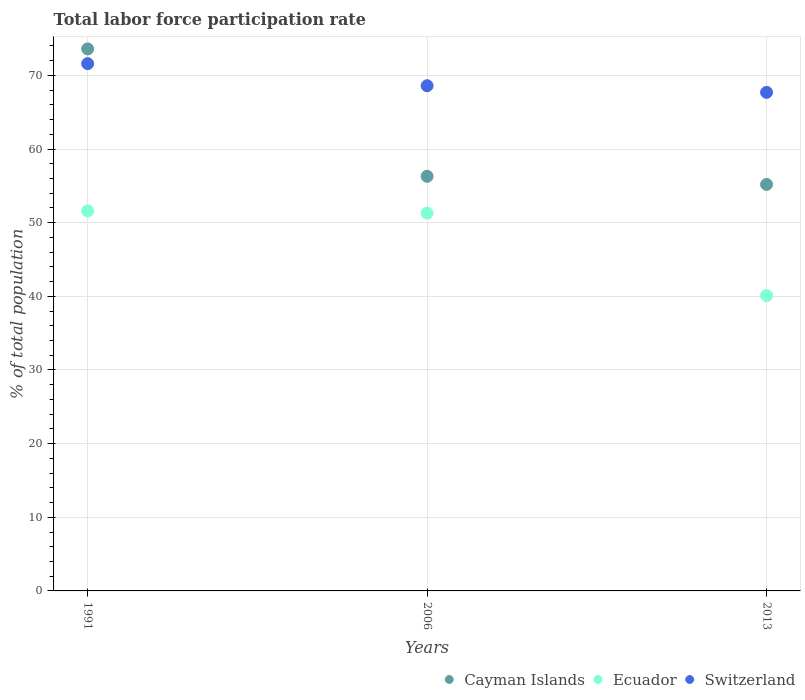What is the total labor force participation rate in Cayman Islands in 1991?
Provide a succinct answer. 73.6. Across all years, what is the maximum total labor force participation rate in Switzerland?
Ensure brevity in your answer.  71.6. Across all years, what is the minimum total labor force participation rate in Switzerland?
Offer a very short reply. 67.7. In which year was the total labor force participation rate in Switzerland maximum?
Make the answer very short. 1991. What is the total total labor force participation rate in Switzerland in the graph?
Ensure brevity in your answer.  207.9. What is the difference between the total labor force participation rate in Ecuador in 1991 and that in 2006?
Keep it short and to the point. 0.3. What is the difference between the total labor force participation rate in Ecuador in 2006 and the total labor force participation rate in Switzerland in 1991?
Your response must be concise. -20.3. What is the average total labor force participation rate in Switzerland per year?
Make the answer very short. 69.3. In how many years, is the total labor force participation rate in Cayman Islands greater than 46 %?
Your answer should be very brief. 3. What is the ratio of the total labor force participation rate in Ecuador in 2006 to that in 2013?
Offer a terse response. 1.28. Is the total labor force participation rate in Cayman Islands in 1991 less than that in 2013?
Provide a succinct answer. No. Is the difference between the total labor force participation rate in Ecuador in 2006 and 2013 greater than the difference between the total labor force participation rate in Cayman Islands in 2006 and 2013?
Keep it short and to the point. Yes. What is the difference between the highest and the second highest total labor force participation rate in Ecuador?
Give a very brief answer. 0.3. What is the difference between the highest and the lowest total labor force participation rate in Switzerland?
Your answer should be very brief. 3.9. In how many years, is the total labor force participation rate in Ecuador greater than the average total labor force participation rate in Ecuador taken over all years?
Provide a short and direct response. 2. Does the total labor force participation rate in Ecuador monotonically increase over the years?
Give a very brief answer. No. Is the total labor force participation rate in Ecuador strictly less than the total labor force participation rate in Cayman Islands over the years?
Your answer should be very brief. Yes. How many dotlines are there?
Provide a succinct answer. 3. What is the title of the graph?
Give a very brief answer. Total labor force participation rate. What is the label or title of the X-axis?
Keep it short and to the point. Years. What is the label or title of the Y-axis?
Give a very brief answer. % of total population. What is the % of total population in Cayman Islands in 1991?
Provide a succinct answer. 73.6. What is the % of total population of Ecuador in 1991?
Provide a short and direct response. 51.6. What is the % of total population of Switzerland in 1991?
Offer a very short reply. 71.6. What is the % of total population of Cayman Islands in 2006?
Keep it short and to the point. 56.3. What is the % of total population in Ecuador in 2006?
Your answer should be compact. 51.3. What is the % of total population of Switzerland in 2006?
Provide a short and direct response. 68.6. What is the % of total population of Cayman Islands in 2013?
Provide a succinct answer. 55.2. What is the % of total population of Ecuador in 2013?
Make the answer very short. 40.1. What is the % of total population of Switzerland in 2013?
Offer a terse response. 67.7. Across all years, what is the maximum % of total population in Cayman Islands?
Ensure brevity in your answer.  73.6. Across all years, what is the maximum % of total population in Ecuador?
Offer a terse response. 51.6. Across all years, what is the maximum % of total population in Switzerland?
Make the answer very short. 71.6. Across all years, what is the minimum % of total population in Cayman Islands?
Give a very brief answer. 55.2. Across all years, what is the minimum % of total population in Ecuador?
Offer a very short reply. 40.1. Across all years, what is the minimum % of total population of Switzerland?
Your answer should be very brief. 67.7. What is the total % of total population in Cayman Islands in the graph?
Give a very brief answer. 185.1. What is the total % of total population in Ecuador in the graph?
Your answer should be compact. 143. What is the total % of total population of Switzerland in the graph?
Your response must be concise. 207.9. What is the difference between the % of total population of Ecuador in 1991 and that in 2013?
Give a very brief answer. 11.5. What is the difference between the % of total population in Ecuador in 2006 and that in 2013?
Keep it short and to the point. 11.2. What is the difference between the % of total population in Cayman Islands in 1991 and the % of total population in Ecuador in 2006?
Give a very brief answer. 22.3. What is the difference between the % of total population in Cayman Islands in 1991 and the % of total population in Switzerland in 2006?
Offer a very short reply. 5. What is the difference between the % of total population in Ecuador in 1991 and the % of total population in Switzerland in 2006?
Ensure brevity in your answer.  -17. What is the difference between the % of total population in Cayman Islands in 1991 and the % of total population in Ecuador in 2013?
Your response must be concise. 33.5. What is the difference between the % of total population in Cayman Islands in 1991 and the % of total population in Switzerland in 2013?
Your answer should be very brief. 5.9. What is the difference between the % of total population in Ecuador in 1991 and the % of total population in Switzerland in 2013?
Offer a terse response. -16.1. What is the difference between the % of total population of Ecuador in 2006 and the % of total population of Switzerland in 2013?
Provide a short and direct response. -16.4. What is the average % of total population of Cayman Islands per year?
Give a very brief answer. 61.7. What is the average % of total population in Ecuador per year?
Offer a terse response. 47.67. What is the average % of total population of Switzerland per year?
Offer a terse response. 69.3. In the year 1991, what is the difference between the % of total population of Cayman Islands and % of total population of Ecuador?
Keep it short and to the point. 22. In the year 2006, what is the difference between the % of total population in Cayman Islands and % of total population in Ecuador?
Ensure brevity in your answer.  5. In the year 2006, what is the difference between the % of total population of Cayman Islands and % of total population of Switzerland?
Your response must be concise. -12.3. In the year 2006, what is the difference between the % of total population of Ecuador and % of total population of Switzerland?
Your answer should be very brief. -17.3. In the year 2013, what is the difference between the % of total population in Cayman Islands and % of total population in Switzerland?
Provide a succinct answer. -12.5. In the year 2013, what is the difference between the % of total population of Ecuador and % of total population of Switzerland?
Keep it short and to the point. -27.6. What is the ratio of the % of total population of Cayman Islands in 1991 to that in 2006?
Your answer should be very brief. 1.31. What is the ratio of the % of total population of Ecuador in 1991 to that in 2006?
Give a very brief answer. 1.01. What is the ratio of the % of total population in Switzerland in 1991 to that in 2006?
Ensure brevity in your answer.  1.04. What is the ratio of the % of total population in Cayman Islands in 1991 to that in 2013?
Make the answer very short. 1.33. What is the ratio of the % of total population of Ecuador in 1991 to that in 2013?
Give a very brief answer. 1.29. What is the ratio of the % of total population of Switzerland in 1991 to that in 2013?
Provide a succinct answer. 1.06. What is the ratio of the % of total population in Cayman Islands in 2006 to that in 2013?
Provide a short and direct response. 1.02. What is the ratio of the % of total population of Ecuador in 2006 to that in 2013?
Give a very brief answer. 1.28. What is the ratio of the % of total population of Switzerland in 2006 to that in 2013?
Your answer should be compact. 1.01. What is the difference between the highest and the second highest % of total population of Cayman Islands?
Provide a short and direct response. 17.3. What is the difference between the highest and the second highest % of total population in Ecuador?
Your answer should be very brief. 0.3. What is the difference between the highest and the lowest % of total population in Cayman Islands?
Your answer should be very brief. 18.4. What is the difference between the highest and the lowest % of total population of Ecuador?
Give a very brief answer. 11.5. What is the difference between the highest and the lowest % of total population in Switzerland?
Keep it short and to the point. 3.9. 